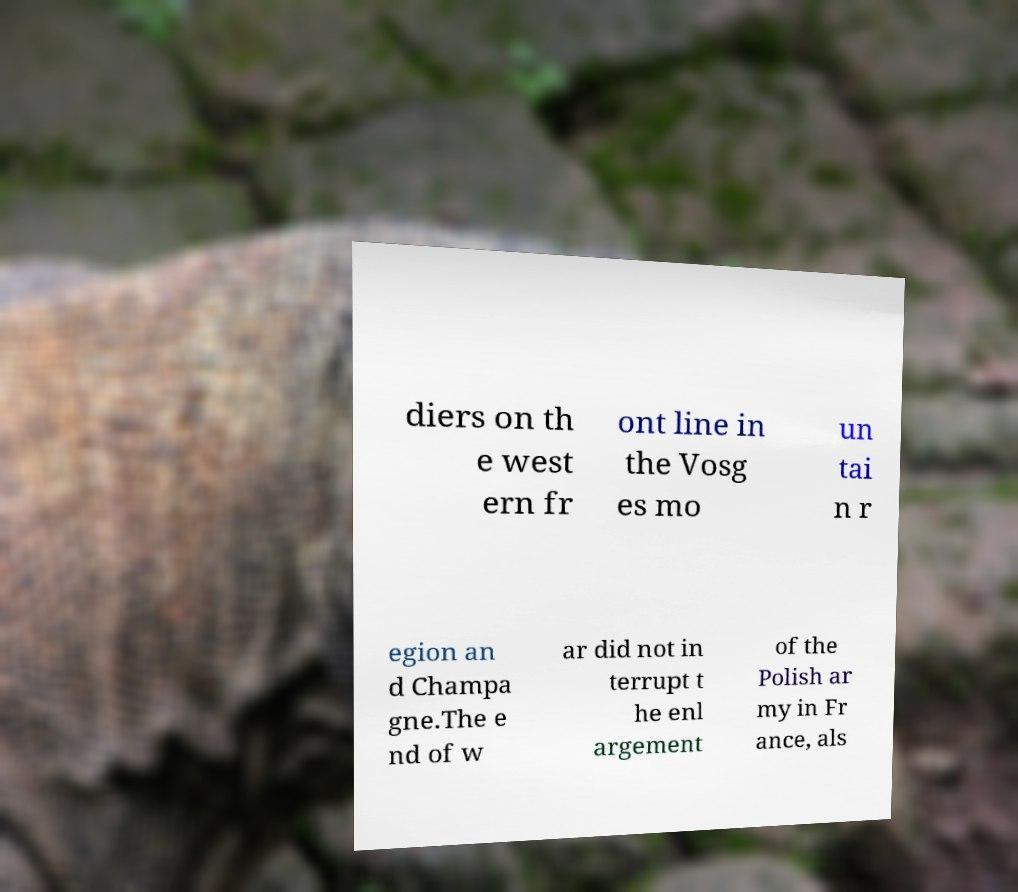Please identify and transcribe the text found in this image. diers on th e west ern fr ont line in the Vosg es mo un tai n r egion an d Champa gne.The e nd of w ar did not in terrupt t he enl argement of the Polish ar my in Fr ance, als 